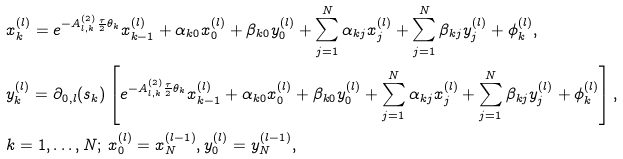<formula> <loc_0><loc_0><loc_500><loc_500>& x _ { k } ^ { ( l ) } = e ^ { - A ^ { ( 2 ) } _ { l , k } \frac { \tau } { 2 } \theta _ { k } } x _ { k - 1 } ^ { ( l ) } + \alpha _ { k 0 } x _ { 0 } ^ { ( l ) } + \beta _ { k 0 } y _ { 0 } ^ { ( l ) } + \sum _ { j = 1 } ^ { N } \alpha _ { k j } x _ { j } ^ { ( l ) } + \sum _ { j = 1 } ^ { N } \beta _ { k j } y _ { j } ^ { ( l ) } + \phi _ { k } ^ { ( l ) } , \\ & y _ { k } ^ { ( l ) } = \partial _ { 0 , l } ( s _ { k } ) \left [ e ^ { - A ^ { ( 2 ) } _ { l , k } \frac { \tau } { 2 } \theta _ { k } } x _ { k - 1 } ^ { ( l ) } + \alpha _ { k 0 } x _ { 0 } ^ { ( l ) } + \beta _ { k 0 } y _ { 0 } ^ { ( l ) } + \sum _ { j = 1 } ^ { N } \alpha _ { k j } x _ { j } ^ { ( l ) } + \sum _ { j = 1 } ^ { N } \beta _ { k j } y _ { j } ^ { ( l ) } + \phi _ { k } ^ { ( l ) } \right ] , \\ & k = 1 , \dots , N ; \, x _ { 0 } ^ { ( l ) } = x _ { N } ^ { ( l - 1 ) } , y _ { 0 } ^ { ( l ) } = y _ { N } ^ { ( l - 1 ) } ,</formula> 